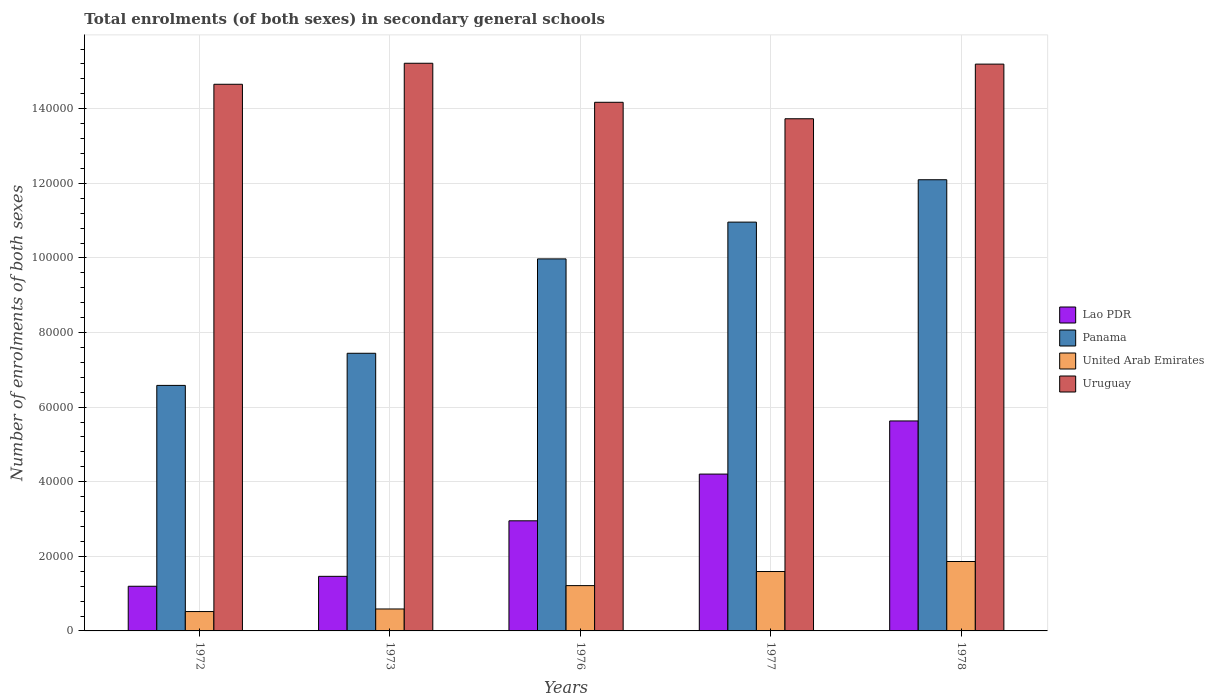How many different coloured bars are there?
Offer a terse response. 4. How many groups of bars are there?
Make the answer very short. 5. How many bars are there on the 3rd tick from the left?
Offer a very short reply. 4. What is the label of the 2nd group of bars from the left?
Your answer should be very brief. 1973. In how many cases, is the number of bars for a given year not equal to the number of legend labels?
Keep it short and to the point. 0. What is the number of enrolments in secondary schools in Lao PDR in 1972?
Keep it short and to the point. 1.20e+04. Across all years, what is the maximum number of enrolments in secondary schools in Uruguay?
Your answer should be very brief. 1.52e+05. Across all years, what is the minimum number of enrolments in secondary schools in Lao PDR?
Provide a short and direct response. 1.20e+04. In which year was the number of enrolments in secondary schools in Panama maximum?
Offer a terse response. 1978. What is the total number of enrolments in secondary schools in Uruguay in the graph?
Give a very brief answer. 7.30e+05. What is the difference between the number of enrolments in secondary schools in Uruguay in 1973 and that in 1977?
Offer a very short reply. 1.49e+04. What is the difference between the number of enrolments in secondary schools in Panama in 1977 and the number of enrolments in secondary schools in Lao PDR in 1972?
Your answer should be very brief. 9.76e+04. What is the average number of enrolments in secondary schools in Uruguay per year?
Offer a terse response. 1.46e+05. In the year 1977, what is the difference between the number of enrolments in secondary schools in United Arab Emirates and number of enrolments in secondary schools in Uruguay?
Your answer should be compact. -1.21e+05. In how many years, is the number of enrolments in secondary schools in Panama greater than 36000?
Provide a succinct answer. 5. What is the ratio of the number of enrolments in secondary schools in Lao PDR in 1976 to that in 1977?
Your answer should be compact. 0.7. What is the difference between the highest and the second highest number of enrolments in secondary schools in Panama?
Provide a short and direct response. 1.14e+04. What is the difference between the highest and the lowest number of enrolments in secondary schools in Uruguay?
Provide a short and direct response. 1.49e+04. In how many years, is the number of enrolments in secondary schools in Lao PDR greater than the average number of enrolments in secondary schools in Lao PDR taken over all years?
Provide a short and direct response. 2. What does the 2nd bar from the left in 1977 represents?
Provide a succinct answer. Panama. What does the 2nd bar from the right in 1976 represents?
Your answer should be compact. United Arab Emirates. How many bars are there?
Offer a terse response. 20. How many years are there in the graph?
Provide a short and direct response. 5. What is the difference between two consecutive major ticks on the Y-axis?
Offer a very short reply. 2.00e+04. Are the values on the major ticks of Y-axis written in scientific E-notation?
Provide a succinct answer. No. How many legend labels are there?
Give a very brief answer. 4. What is the title of the graph?
Provide a short and direct response. Total enrolments (of both sexes) in secondary general schools. Does "Luxembourg" appear as one of the legend labels in the graph?
Give a very brief answer. No. What is the label or title of the X-axis?
Provide a succinct answer. Years. What is the label or title of the Y-axis?
Make the answer very short. Number of enrolments of both sexes. What is the Number of enrolments of both sexes of Lao PDR in 1972?
Your response must be concise. 1.20e+04. What is the Number of enrolments of both sexes in Panama in 1972?
Keep it short and to the point. 6.58e+04. What is the Number of enrolments of both sexes of United Arab Emirates in 1972?
Provide a succinct answer. 5194. What is the Number of enrolments of both sexes of Uruguay in 1972?
Provide a succinct answer. 1.47e+05. What is the Number of enrolments of both sexes in Lao PDR in 1973?
Provide a succinct answer. 1.46e+04. What is the Number of enrolments of both sexes of Panama in 1973?
Give a very brief answer. 7.44e+04. What is the Number of enrolments of both sexes in United Arab Emirates in 1973?
Give a very brief answer. 5884. What is the Number of enrolments of both sexes of Uruguay in 1973?
Provide a succinct answer. 1.52e+05. What is the Number of enrolments of both sexes of Lao PDR in 1976?
Offer a terse response. 2.95e+04. What is the Number of enrolments of both sexes in Panama in 1976?
Give a very brief answer. 9.97e+04. What is the Number of enrolments of both sexes in United Arab Emirates in 1976?
Keep it short and to the point. 1.21e+04. What is the Number of enrolments of both sexes in Uruguay in 1976?
Give a very brief answer. 1.42e+05. What is the Number of enrolments of both sexes of Lao PDR in 1977?
Your answer should be very brief. 4.20e+04. What is the Number of enrolments of both sexes of Panama in 1977?
Provide a succinct answer. 1.10e+05. What is the Number of enrolments of both sexes in United Arab Emirates in 1977?
Give a very brief answer. 1.59e+04. What is the Number of enrolments of both sexes in Uruguay in 1977?
Keep it short and to the point. 1.37e+05. What is the Number of enrolments of both sexes in Lao PDR in 1978?
Offer a terse response. 5.63e+04. What is the Number of enrolments of both sexes in Panama in 1978?
Provide a short and direct response. 1.21e+05. What is the Number of enrolments of both sexes of United Arab Emirates in 1978?
Offer a very short reply. 1.86e+04. What is the Number of enrolments of both sexes in Uruguay in 1978?
Your answer should be compact. 1.52e+05. Across all years, what is the maximum Number of enrolments of both sexes of Lao PDR?
Keep it short and to the point. 5.63e+04. Across all years, what is the maximum Number of enrolments of both sexes in Panama?
Your answer should be very brief. 1.21e+05. Across all years, what is the maximum Number of enrolments of both sexes of United Arab Emirates?
Provide a succinct answer. 1.86e+04. Across all years, what is the maximum Number of enrolments of both sexes in Uruguay?
Offer a very short reply. 1.52e+05. Across all years, what is the minimum Number of enrolments of both sexes in Lao PDR?
Ensure brevity in your answer.  1.20e+04. Across all years, what is the minimum Number of enrolments of both sexes in Panama?
Offer a terse response. 6.58e+04. Across all years, what is the minimum Number of enrolments of both sexes in United Arab Emirates?
Make the answer very short. 5194. Across all years, what is the minimum Number of enrolments of both sexes in Uruguay?
Offer a terse response. 1.37e+05. What is the total Number of enrolments of both sexes in Lao PDR in the graph?
Ensure brevity in your answer.  1.54e+05. What is the total Number of enrolments of both sexes of Panama in the graph?
Provide a succinct answer. 4.71e+05. What is the total Number of enrolments of both sexes of United Arab Emirates in the graph?
Provide a short and direct response. 5.78e+04. What is the total Number of enrolments of both sexes of Uruguay in the graph?
Your response must be concise. 7.30e+05. What is the difference between the Number of enrolments of both sexes of Lao PDR in 1972 and that in 1973?
Give a very brief answer. -2657. What is the difference between the Number of enrolments of both sexes of Panama in 1972 and that in 1973?
Offer a terse response. -8614. What is the difference between the Number of enrolments of both sexes of United Arab Emirates in 1972 and that in 1973?
Provide a succinct answer. -690. What is the difference between the Number of enrolments of both sexes in Uruguay in 1972 and that in 1973?
Provide a short and direct response. -5635. What is the difference between the Number of enrolments of both sexes of Lao PDR in 1972 and that in 1976?
Your answer should be very brief. -1.75e+04. What is the difference between the Number of enrolments of both sexes in Panama in 1972 and that in 1976?
Provide a short and direct response. -3.39e+04. What is the difference between the Number of enrolments of both sexes of United Arab Emirates in 1972 and that in 1976?
Provide a short and direct response. -6954. What is the difference between the Number of enrolments of both sexes in Uruguay in 1972 and that in 1976?
Your answer should be compact. 4828. What is the difference between the Number of enrolments of both sexes in Lao PDR in 1972 and that in 1977?
Provide a short and direct response. -3.01e+04. What is the difference between the Number of enrolments of both sexes of Panama in 1972 and that in 1977?
Your response must be concise. -4.38e+04. What is the difference between the Number of enrolments of both sexes of United Arab Emirates in 1972 and that in 1977?
Your response must be concise. -1.07e+04. What is the difference between the Number of enrolments of both sexes of Uruguay in 1972 and that in 1977?
Offer a terse response. 9244. What is the difference between the Number of enrolments of both sexes of Lao PDR in 1972 and that in 1978?
Give a very brief answer. -4.43e+04. What is the difference between the Number of enrolments of both sexes of Panama in 1972 and that in 1978?
Ensure brevity in your answer.  -5.51e+04. What is the difference between the Number of enrolments of both sexes of United Arab Emirates in 1972 and that in 1978?
Your answer should be very brief. -1.34e+04. What is the difference between the Number of enrolments of both sexes in Uruguay in 1972 and that in 1978?
Your answer should be very brief. -5403. What is the difference between the Number of enrolments of both sexes of Lao PDR in 1973 and that in 1976?
Keep it short and to the point. -1.49e+04. What is the difference between the Number of enrolments of both sexes in Panama in 1973 and that in 1976?
Your response must be concise. -2.53e+04. What is the difference between the Number of enrolments of both sexes of United Arab Emirates in 1973 and that in 1976?
Provide a succinct answer. -6264. What is the difference between the Number of enrolments of both sexes in Uruguay in 1973 and that in 1976?
Your response must be concise. 1.05e+04. What is the difference between the Number of enrolments of both sexes of Lao PDR in 1973 and that in 1977?
Make the answer very short. -2.74e+04. What is the difference between the Number of enrolments of both sexes in Panama in 1973 and that in 1977?
Your answer should be compact. -3.52e+04. What is the difference between the Number of enrolments of both sexes of United Arab Emirates in 1973 and that in 1977?
Keep it short and to the point. -1.00e+04. What is the difference between the Number of enrolments of both sexes of Uruguay in 1973 and that in 1977?
Your answer should be compact. 1.49e+04. What is the difference between the Number of enrolments of both sexes in Lao PDR in 1973 and that in 1978?
Your answer should be compact. -4.17e+04. What is the difference between the Number of enrolments of both sexes in Panama in 1973 and that in 1978?
Your response must be concise. -4.65e+04. What is the difference between the Number of enrolments of both sexes in United Arab Emirates in 1973 and that in 1978?
Give a very brief answer. -1.27e+04. What is the difference between the Number of enrolments of both sexes of Uruguay in 1973 and that in 1978?
Offer a terse response. 232. What is the difference between the Number of enrolments of both sexes in Lao PDR in 1976 and that in 1977?
Provide a short and direct response. -1.25e+04. What is the difference between the Number of enrolments of both sexes of Panama in 1976 and that in 1977?
Your response must be concise. -9859. What is the difference between the Number of enrolments of both sexes of United Arab Emirates in 1976 and that in 1977?
Make the answer very short. -3779. What is the difference between the Number of enrolments of both sexes in Uruguay in 1976 and that in 1977?
Keep it short and to the point. 4416. What is the difference between the Number of enrolments of both sexes in Lao PDR in 1976 and that in 1978?
Make the answer very short. -2.68e+04. What is the difference between the Number of enrolments of both sexes of Panama in 1976 and that in 1978?
Provide a short and direct response. -2.12e+04. What is the difference between the Number of enrolments of both sexes of United Arab Emirates in 1976 and that in 1978?
Offer a terse response. -6462. What is the difference between the Number of enrolments of both sexes of Uruguay in 1976 and that in 1978?
Give a very brief answer. -1.02e+04. What is the difference between the Number of enrolments of both sexes in Lao PDR in 1977 and that in 1978?
Offer a terse response. -1.42e+04. What is the difference between the Number of enrolments of both sexes of Panama in 1977 and that in 1978?
Ensure brevity in your answer.  -1.14e+04. What is the difference between the Number of enrolments of both sexes in United Arab Emirates in 1977 and that in 1978?
Give a very brief answer. -2683. What is the difference between the Number of enrolments of both sexes in Uruguay in 1977 and that in 1978?
Your response must be concise. -1.46e+04. What is the difference between the Number of enrolments of both sexes of Lao PDR in 1972 and the Number of enrolments of both sexes of Panama in 1973?
Your response must be concise. -6.25e+04. What is the difference between the Number of enrolments of both sexes of Lao PDR in 1972 and the Number of enrolments of both sexes of United Arab Emirates in 1973?
Offer a very short reply. 6092. What is the difference between the Number of enrolments of both sexes of Lao PDR in 1972 and the Number of enrolments of both sexes of Uruguay in 1973?
Make the answer very short. -1.40e+05. What is the difference between the Number of enrolments of both sexes in Panama in 1972 and the Number of enrolments of both sexes in United Arab Emirates in 1973?
Your answer should be compact. 5.99e+04. What is the difference between the Number of enrolments of both sexes of Panama in 1972 and the Number of enrolments of both sexes of Uruguay in 1973?
Provide a short and direct response. -8.64e+04. What is the difference between the Number of enrolments of both sexes of United Arab Emirates in 1972 and the Number of enrolments of both sexes of Uruguay in 1973?
Your answer should be compact. -1.47e+05. What is the difference between the Number of enrolments of both sexes of Lao PDR in 1972 and the Number of enrolments of both sexes of Panama in 1976?
Give a very brief answer. -8.78e+04. What is the difference between the Number of enrolments of both sexes in Lao PDR in 1972 and the Number of enrolments of both sexes in United Arab Emirates in 1976?
Your answer should be compact. -172. What is the difference between the Number of enrolments of both sexes in Lao PDR in 1972 and the Number of enrolments of both sexes in Uruguay in 1976?
Provide a short and direct response. -1.30e+05. What is the difference between the Number of enrolments of both sexes of Panama in 1972 and the Number of enrolments of both sexes of United Arab Emirates in 1976?
Provide a succinct answer. 5.37e+04. What is the difference between the Number of enrolments of both sexes of Panama in 1972 and the Number of enrolments of both sexes of Uruguay in 1976?
Provide a short and direct response. -7.59e+04. What is the difference between the Number of enrolments of both sexes of United Arab Emirates in 1972 and the Number of enrolments of both sexes of Uruguay in 1976?
Provide a short and direct response. -1.37e+05. What is the difference between the Number of enrolments of both sexes in Lao PDR in 1972 and the Number of enrolments of both sexes in Panama in 1977?
Offer a terse response. -9.76e+04. What is the difference between the Number of enrolments of both sexes of Lao PDR in 1972 and the Number of enrolments of both sexes of United Arab Emirates in 1977?
Offer a terse response. -3951. What is the difference between the Number of enrolments of both sexes of Lao PDR in 1972 and the Number of enrolments of both sexes of Uruguay in 1977?
Ensure brevity in your answer.  -1.25e+05. What is the difference between the Number of enrolments of both sexes in Panama in 1972 and the Number of enrolments of both sexes in United Arab Emirates in 1977?
Provide a short and direct response. 4.99e+04. What is the difference between the Number of enrolments of both sexes of Panama in 1972 and the Number of enrolments of both sexes of Uruguay in 1977?
Keep it short and to the point. -7.15e+04. What is the difference between the Number of enrolments of both sexes of United Arab Emirates in 1972 and the Number of enrolments of both sexes of Uruguay in 1977?
Your answer should be compact. -1.32e+05. What is the difference between the Number of enrolments of both sexes in Lao PDR in 1972 and the Number of enrolments of both sexes in Panama in 1978?
Give a very brief answer. -1.09e+05. What is the difference between the Number of enrolments of both sexes in Lao PDR in 1972 and the Number of enrolments of both sexes in United Arab Emirates in 1978?
Provide a succinct answer. -6634. What is the difference between the Number of enrolments of both sexes in Lao PDR in 1972 and the Number of enrolments of both sexes in Uruguay in 1978?
Your answer should be very brief. -1.40e+05. What is the difference between the Number of enrolments of both sexes of Panama in 1972 and the Number of enrolments of both sexes of United Arab Emirates in 1978?
Keep it short and to the point. 4.72e+04. What is the difference between the Number of enrolments of both sexes of Panama in 1972 and the Number of enrolments of both sexes of Uruguay in 1978?
Your response must be concise. -8.61e+04. What is the difference between the Number of enrolments of both sexes in United Arab Emirates in 1972 and the Number of enrolments of both sexes in Uruguay in 1978?
Ensure brevity in your answer.  -1.47e+05. What is the difference between the Number of enrolments of both sexes in Lao PDR in 1973 and the Number of enrolments of both sexes in Panama in 1976?
Your answer should be compact. -8.51e+04. What is the difference between the Number of enrolments of both sexes in Lao PDR in 1973 and the Number of enrolments of both sexes in United Arab Emirates in 1976?
Give a very brief answer. 2485. What is the difference between the Number of enrolments of both sexes of Lao PDR in 1973 and the Number of enrolments of both sexes of Uruguay in 1976?
Provide a succinct answer. -1.27e+05. What is the difference between the Number of enrolments of both sexes in Panama in 1973 and the Number of enrolments of both sexes in United Arab Emirates in 1976?
Your response must be concise. 6.23e+04. What is the difference between the Number of enrolments of both sexes of Panama in 1973 and the Number of enrolments of both sexes of Uruguay in 1976?
Your response must be concise. -6.73e+04. What is the difference between the Number of enrolments of both sexes of United Arab Emirates in 1973 and the Number of enrolments of both sexes of Uruguay in 1976?
Provide a succinct answer. -1.36e+05. What is the difference between the Number of enrolments of both sexes in Lao PDR in 1973 and the Number of enrolments of both sexes in Panama in 1977?
Offer a very short reply. -9.50e+04. What is the difference between the Number of enrolments of both sexes of Lao PDR in 1973 and the Number of enrolments of both sexes of United Arab Emirates in 1977?
Provide a succinct answer. -1294. What is the difference between the Number of enrolments of both sexes of Lao PDR in 1973 and the Number of enrolments of both sexes of Uruguay in 1977?
Offer a very short reply. -1.23e+05. What is the difference between the Number of enrolments of both sexes in Panama in 1973 and the Number of enrolments of both sexes in United Arab Emirates in 1977?
Your answer should be compact. 5.85e+04. What is the difference between the Number of enrolments of both sexes of Panama in 1973 and the Number of enrolments of both sexes of Uruguay in 1977?
Your response must be concise. -6.29e+04. What is the difference between the Number of enrolments of both sexes of United Arab Emirates in 1973 and the Number of enrolments of both sexes of Uruguay in 1977?
Offer a very short reply. -1.31e+05. What is the difference between the Number of enrolments of both sexes in Lao PDR in 1973 and the Number of enrolments of both sexes in Panama in 1978?
Ensure brevity in your answer.  -1.06e+05. What is the difference between the Number of enrolments of both sexes of Lao PDR in 1973 and the Number of enrolments of both sexes of United Arab Emirates in 1978?
Your answer should be compact. -3977. What is the difference between the Number of enrolments of both sexes of Lao PDR in 1973 and the Number of enrolments of both sexes of Uruguay in 1978?
Keep it short and to the point. -1.37e+05. What is the difference between the Number of enrolments of both sexes of Panama in 1973 and the Number of enrolments of both sexes of United Arab Emirates in 1978?
Provide a succinct answer. 5.58e+04. What is the difference between the Number of enrolments of both sexes of Panama in 1973 and the Number of enrolments of both sexes of Uruguay in 1978?
Keep it short and to the point. -7.75e+04. What is the difference between the Number of enrolments of both sexes of United Arab Emirates in 1973 and the Number of enrolments of both sexes of Uruguay in 1978?
Your answer should be compact. -1.46e+05. What is the difference between the Number of enrolments of both sexes of Lao PDR in 1976 and the Number of enrolments of both sexes of Panama in 1977?
Your answer should be very brief. -8.01e+04. What is the difference between the Number of enrolments of both sexes of Lao PDR in 1976 and the Number of enrolments of both sexes of United Arab Emirates in 1977?
Offer a terse response. 1.36e+04. What is the difference between the Number of enrolments of both sexes in Lao PDR in 1976 and the Number of enrolments of both sexes in Uruguay in 1977?
Offer a terse response. -1.08e+05. What is the difference between the Number of enrolments of both sexes in Panama in 1976 and the Number of enrolments of both sexes in United Arab Emirates in 1977?
Offer a terse response. 8.38e+04. What is the difference between the Number of enrolments of both sexes in Panama in 1976 and the Number of enrolments of both sexes in Uruguay in 1977?
Offer a very short reply. -3.76e+04. What is the difference between the Number of enrolments of both sexes of United Arab Emirates in 1976 and the Number of enrolments of both sexes of Uruguay in 1977?
Offer a very short reply. -1.25e+05. What is the difference between the Number of enrolments of both sexes in Lao PDR in 1976 and the Number of enrolments of both sexes in Panama in 1978?
Provide a short and direct response. -9.14e+04. What is the difference between the Number of enrolments of both sexes of Lao PDR in 1976 and the Number of enrolments of both sexes of United Arab Emirates in 1978?
Your answer should be compact. 1.09e+04. What is the difference between the Number of enrolments of both sexes of Lao PDR in 1976 and the Number of enrolments of both sexes of Uruguay in 1978?
Keep it short and to the point. -1.22e+05. What is the difference between the Number of enrolments of both sexes in Panama in 1976 and the Number of enrolments of both sexes in United Arab Emirates in 1978?
Make the answer very short. 8.11e+04. What is the difference between the Number of enrolments of both sexes in Panama in 1976 and the Number of enrolments of both sexes in Uruguay in 1978?
Your response must be concise. -5.22e+04. What is the difference between the Number of enrolments of both sexes in United Arab Emirates in 1976 and the Number of enrolments of both sexes in Uruguay in 1978?
Provide a short and direct response. -1.40e+05. What is the difference between the Number of enrolments of both sexes of Lao PDR in 1977 and the Number of enrolments of both sexes of Panama in 1978?
Give a very brief answer. -7.89e+04. What is the difference between the Number of enrolments of both sexes in Lao PDR in 1977 and the Number of enrolments of both sexes in United Arab Emirates in 1978?
Offer a very short reply. 2.34e+04. What is the difference between the Number of enrolments of both sexes in Lao PDR in 1977 and the Number of enrolments of both sexes in Uruguay in 1978?
Keep it short and to the point. -1.10e+05. What is the difference between the Number of enrolments of both sexes in Panama in 1977 and the Number of enrolments of both sexes in United Arab Emirates in 1978?
Your response must be concise. 9.10e+04. What is the difference between the Number of enrolments of both sexes in Panama in 1977 and the Number of enrolments of both sexes in Uruguay in 1978?
Provide a short and direct response. -4.24e+04. What is the difference between the Number of enrolments of both sexes in United Arab Emirates in 1977 and the Number of enrolments of both sexes in Uruguay in 1978?
Provide a short and direct response. -1.36e+05. What is the average Number of enrolments of both sexes of Lao PDR per year?
Offer a very short reply. 3.09e+04. What is the average Number of enrolments of both sexes of Panama per year?
Your response must be concise. 9.41e+04. What is the average Number of enrolments of both sexes of United Arab Emirates per year?
Your answer should be compact. 1.16e+04. What is the average Number of enrolments of both sexes of Uruguay per year?
Ensure brevity in your answer.  1.46e+05. In the year 1972, what is the difference between the Number of enrolments of both sexes in Lao PDR and Number of enrolments of both sexes in Panama?
Provide a short and direct response. -5.39e+04. In the year 1972, what is the difference between the Number of enrolments of both sexes of Lao PDR and Number of enrolments of both sexes of United Arab Emirates?
Ensure brevity in your answer.  6782. In the year 1972, what is the difference between the Number of enrolments of both sexes in Lao PDR and Number of enrolments of both sexes in Uruguay?
Make the answer very short. -1.35e+05. In the year 1972, what is the difference between the Number of enrolments of both sexes in Panama and Number of enrolments of both sexes in United Arab Emirates?
Your response must be concise. 6.06e+04. In the year 1972, what is the difference between the Number of enrolments of both sexes in Panama and Number of enrolments of both sexes in Uruguay?
Keep it short and to the point. -8.07e+04. In the year 1972, what is the difference between the Number of enrolments of both sexes of United Arab Emirates and Number of enrolments of both sexes of Uruguay?
Give a very brief answer. -1.41e+05. In the year 1973, what is the difference between the Number of enrolments of both sexes in Lao PDR and Number of enrolments of both sexes in Panama?
Provide a short and direct response. -5.98e+04. In the year 1973, what is the difference between the Number of enrolments of both sexes in Lao PDR and Number of enrolments of both sexes in United Arab Emirates?
Give a very brief answer. 8749. In the year 1973, what is the difference between the Number of enrolments of both sexes in Lao PDR and Number of enrolments of both sexes in Uruguay?
Provide a succinct answer. -1.38e+05. In the year 1973, what is the difference between the Number of enrolments of both sexes in Panama and Number of enrolments of both sexes in United Arab Emirates?
Offer a terse response. 6.86e+04. In the year 1973, what is the difference between the Number of enrolments of both sexes of Panama and Number of enrolments of both sexes of Uruguay?
Give a very brief answer. -7.78e+04. In the year 1973, what is the difference between the Number of enrolments of both sexes in United Arab Emirates and Number of enrolments of both sexes in Uruguay?
Ensure brevity in your answer.  -1.46e+05. In the year 1976, what is the difference between the Number of enrolments of both sexes in Lao PDR and Number of enrolments of both sexes in Panama?
Offer a terse response. -7.02e+04. In the year 1976, what is the difference between the Number of enrolments of both sexes in Lao PDR and Number of enrolments of both sexes in United Arab Emirates?
Your answer should be very brief. 1.74e+04. In the year 1976, what is the difference between the Number of enrolments of both sexes in Lao PDR and Number of enrolments of both sexes in Uruguay?
Make the answer very short. -1.12e+05. In the year 1976, what is the difference between the Number of enrolments of both sexes of Panama and Number of enrolments of both sexes of United Arab Emirates?
Keep it short and to the point. 8.76e+04. In the year 1976, what is the difference between the Number of enrolments of both sexes in Panama and Number of enrolments of both sexes in Uruguay?
Offer a very short reply. -4.20e+04. In the year 1976, what is the difference between the Number of enrolments of both sexes in United Arab Emirates and Number of enrolments of both sexes in Uruguay?
Your answer should be compact. -1.30e+05. In the year 1977, what is the difference between the Number of enrolments of both sexes of Lao PDR and Number of enrolments of both sexes of Panama?
Your answer should be compact. -6.76e+04. In the year 1977, what is the difference between the Number of enrolments of both sexes of Lao PDR and Number of enrolments of both sexes of United Arab Emirates?
Provide a succinct answer. 2.61e+04. In the year 1977, what is the difference between the Number of enrolments of both sexes of Lao PDR and Number of enrolments of both sexes of Uruguay?
Keep it short and to the point. -9.53e+04. In the year 1977, what is the difference between the Number of enrolments of both sexes of Panama and Number of enrolments of both sexes of United Arab Emirates?
Ensure brevity in your answer.  9.37e+04. In the year 1977, what is the difference between the Number of enrolments of both sexes in Panama and Number of enrolments of both sexes in Uruguay?
Keep it short and to the point. -2.77e+04. In the year 1977, what is the difference between the Number of enrolments of both sexes of United Arab Emirates and Number of enrolments of both sexes of Uruguay?
Your answer should be compact. -1.21e+05. In the year 1978, what is the difference between the Number of enrolments of both sexes of Lao PDR and Number of enrolments of both sexes of Panama?
Offer a terse response. -6.47e+04. In the year 1978, what is the difference between the Number of enrolments of both sexes in Lao PDR and Number of enrolments of both sexes in United Arab Emirates?
Your response must be concise. 3.77e+04. In the year 1978, what is the difference between the Number of enrolments of both sexes in Lao PDR and Number of enrolments of both sexes in Uruguay?
Offer a very short reply. -9.57e+04. In the year 1978, what is the difference between the Number of enrolments of both sexes in Panama and Number of enrolments of both sexes in United Arab Emirates?
Give a very brief answer. 1.02e+05. In the year 1978, what is the difference between the Number of enrolments of both sexes of Panama and Number of enrolments of both sexes of Uruguay?
Your answer should be very brief. -3.10e+04. In the year 1978, what is the difference between the Number of enrolments of both sexes of United Arab Emirates and Number of enrolments of both sexes of Uruguay?
Provide a short and direct response. -1.33e+05. What is the ratio of the Number of enrolments of both sexes in Lao PDR in 1972 to that in 1973?
Keep it short and to the point. 0.82. What is the ratio of the Number of enrolments of both sexes in Panama in 1972 to that in 1973?
Ensure brevity in your answer.  0.88. What is the ratio of the Number of enrolments of both sexes in United Arab Emirates in 1972 to that in 1973?
Offer a terse response. 0.88. What is the ratio of the Number of enrolments of both sexes in Uruguay in 1972 to that in 1973?
Offer a terse response. 0.96. What is the ratio of the Number of enrolments of both sexes in Lao PDR in 1972 to that in 1976?
Keep it short and to the point. 0.41. What is the ratio of the Number of enrolments of both sexes in Panama in 1972 to that in 1976?
Provide a short and direct response. 0.66. What is the ratio of the Number of enrolments of both sexes in United Arab Emirates in 1972 to that in 1976?
Make the answer very short. 0.43. What is the ratio of the Number of enrolments of both sexes of Uruguay in 1972 to that in 1976?
Your response must be concise. 1.03. What is the ratio of the Number of enrolments of both sexes in Lao PDR in 1972 to that in 1977?
Your answer should be compact. 0.28. What is the ratio of the Number of enrolments of both sexes of Panama in 1972 to that in 1977?
Your answer should be very brief. 0.6. What is the ratio of the Number of enrolments of both sexes of United Arab Emirates in 1972 to that in 1977?
Provide a succinct answer. 0.33. What is the ratio of the Number of enrolments of both sexes in Uruguay in 1972 to that in 1977?
Provide a short and direct response. 1.07. What is the ratio of the Number of enrolments of both sexes in Lao PDR in 1972 to that in 1978?
Keep it short and to the point. 0.21. What is the ratio of the Number of enrolments of both sexes of Panama in 1972 to that in 1978?
Make the answer very short. 0.54. What is the ratio of the Number of enrolments of both sexes of United Arab Emirates in 1972 to that in 1978?
Offer a terse response. 0.28. What is the ratio of the Number of enrolments of both sexes of Uruguay in 1972 to that in 1978?
Make the answer very short. 0.96. What is the ratio of the Number of enrolments of both sexes in Lao PDR in 1973 to that in 1976?
Your answer should be very brief. 0.5. What is the ratio of the Number of enrolments of both sexes in Panama in 1973 to that in 1976?
Keep it short and to the point. 0.75. What is the ratio of the Number of enrolments of both sexes of United Arab Emirates in 1973 to that in 1976?
Provide a succinct answer. 0.48. What is the ratio of the Number of enrolments of both sexes in Uruguay in 1973 to that in 1976?
Your response must be concise. 1.07. What is the ratio of the Number of enrolments of both sexes in Lao PDR in 1973 to that in 1977?
Ensure brevity in your answer.  0.35. What is the ratio of the Number of enrolments of both sexes of Panama in 1973 to that in 1977?
Your answer should be compact. 0.68. What is the ratio of the Number of enrolments of both sexes in United Arab Emirates in 1973 to that in 1977?
Ensure brevity in your answer.  0.37. What is the ratio of the Number of enrolments of both sexes in Uruguay in 1973 to that in 1977?
Your response must be concise. 1.11. What is the ratio of the Number of enrolments of both sexes of Lao PDR in 1973 to that in 1978?
Your answer should be compact. 0.26. What is the ratio of the Number of enrolments of both sexes of Panama in 1973 to that in 1978?
Make the answer very short. 0.62. What is the ratio of the Number of enrolments of both sexes of United Arab Emirates in 1973 to that in 1978?
Your answer should be very brief. 0.32. What is the ratio of the Number of enrolments of both sexes in Lao PDR in 1976 to that in 1977?
Make the answer very short. 0.7. What is the ratio of the Number of enrolments of both sexes in Panama in 1976 to that in 1977?
Provide a short and direct response. 0.91. What is the ratio of the Number of enrolments of both sexes in United Arab Emirates in 1976 to that in 1977?
Provide a short and direct response. 0.76. What is the ratio of the Number of enrolments of both sexes in Uruguay in 1976 to that in 1977?
Provide a succinct answer. 1.03. What is the ratio of the Number of enrolments of both sexes in Lao PDR in 1976 to that in 1978?
Provide a short and direct response. 0.52. What is the ratio of the Number of enrolments of both sexes of Panama in 1976 to that in 1978?
Offer a very short reply. 0.82. What is the ratio of the Number of enrolments of both sexes of United Arab Emirates in 1976 to that in 1978?
Offer a terse response. 0.65. What is the ratio of the Number of enrolments of both sexes in Uruguay in 1976 to that in 1978?
Ensure brevity in your answer.  0.93. What is the ratio of the Number of enrolments of both sexes of Lao PDR in 1977 to that in 1978?
Offer a very short reply. 0.75. What is the ratio of the Number of enrolments of both sexes in Panama in 1977 to that in 1978?
Your answer should be compact. 0.91. What is the ratio of the Number of enrolments of both sexes in United Arab Emirates in 1977 to that in 1978?
Your answer should be very brief. 0.86. What is the ratio of the Number of enrolments of both sexes of Uruguay in 1977 to that in 1978?
Your response must be concise. 0.9. What is the difference between the highest and the second highest Number of enrolments of both sexes of Lao PDR?
Offer a very short reply. 1.42e+04. What is the difference between the highest and the second highest Number of enrolments of both sexes in Panama?
Provide a short and direct response. 1.14e+04. What is the difference between the highest and the second highest Number of enrolments of both sexes of United Arab Emirates?
Your answer should be very brief. 2683. What is the difference between the highest and the second highest Number of enrolments of both sexes in Uruguay?
Your answer should be very brief. 232. What is the difference between the highest and the lowest Number of enrolments of both sexes in Lao PDR?
Provide a short and direct response. 4.43e+04. What is the difference between the highest and the lowest Number of enrolments of both sexes of Panama?
Your answer should be very brief. 5.51e+04. What is the difference between the highest and the lowest Number of enrolments of both sexes in United Arab Emirates?
Provide a short and direct response. 1.34e+04. What is the difference between the highest and the lowest Number of enrolments of both sexes of Uruguay?
Make the answer very short. 1.49e+04. 